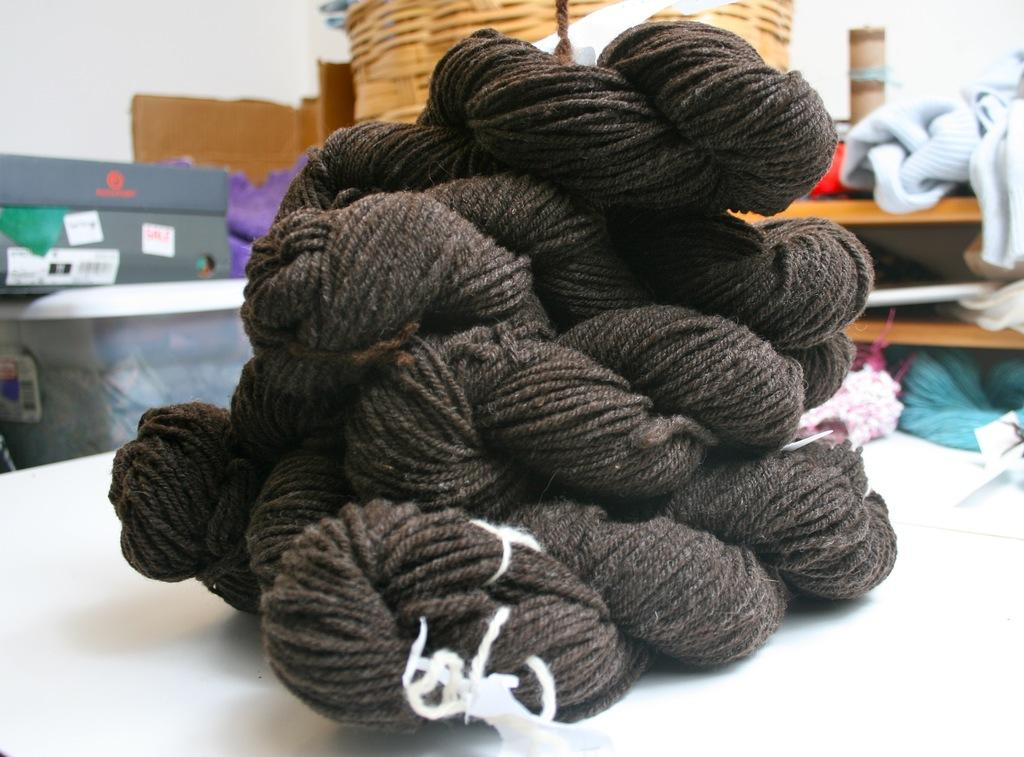What material is present on the table in the image? There is wool on a table in the image. What type of clothing can be seen in the background of the image? There are woolen clothes in the background of the image. What type of containers are visible in the background of the image? There are boxes and baskets in the background of the image. Can you describe any other items visible in the background of the image? There are other unspecified items in the background of the image. What type of wall decoration can be seen in the image? There is no wall decoration present in the image. How many beetles can be seen crawling on the wool in the image? There are no beetles present in the image. 